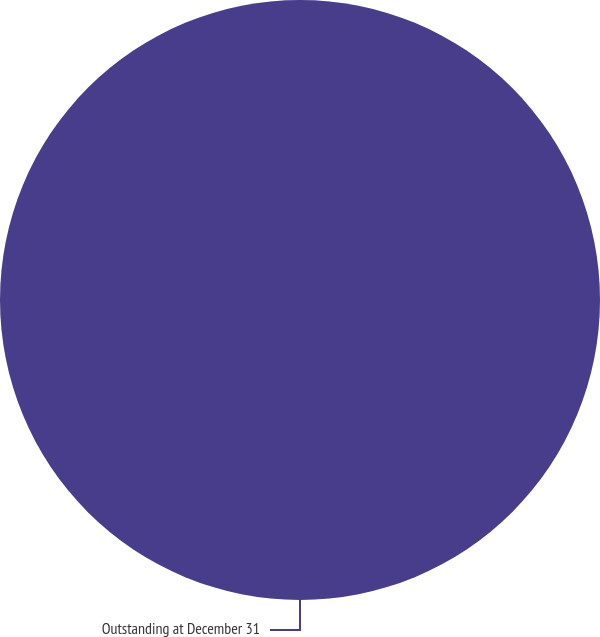Convert chart. <chart><loc_0><loc_0><loc_500><loc_500><pie_chart><fcel>Outstanding at December 31<nl><fcel>100.0%<nl></chart> 